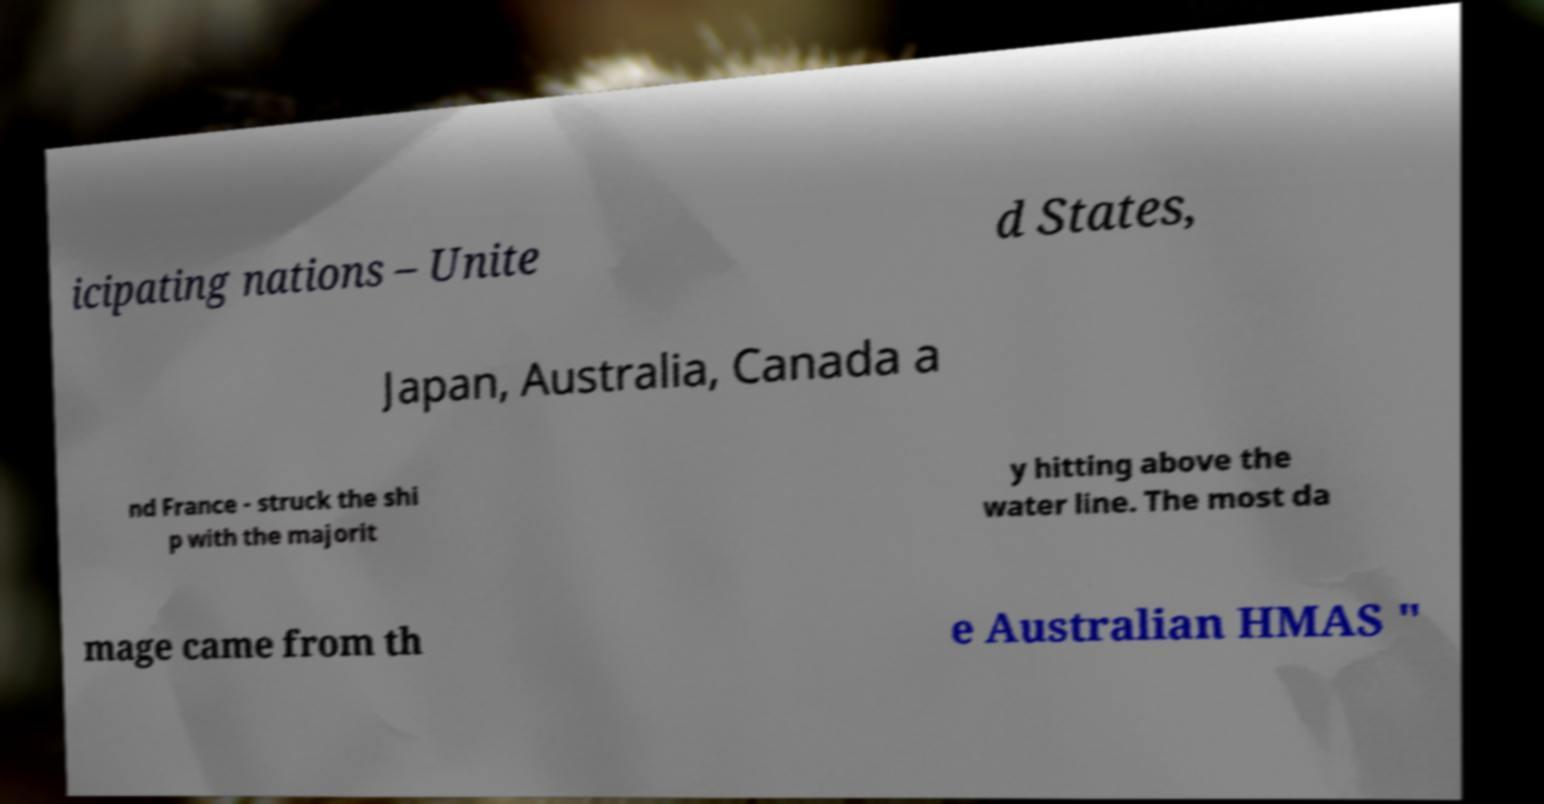Please read and relay the text visible in this image. What does it say? icipating nations – Unite d States, Japan, Australia, Canada a nd France - struck the shi p with the majorit y hitting above the water line. The most da mage came from th e Australian HMAS " 